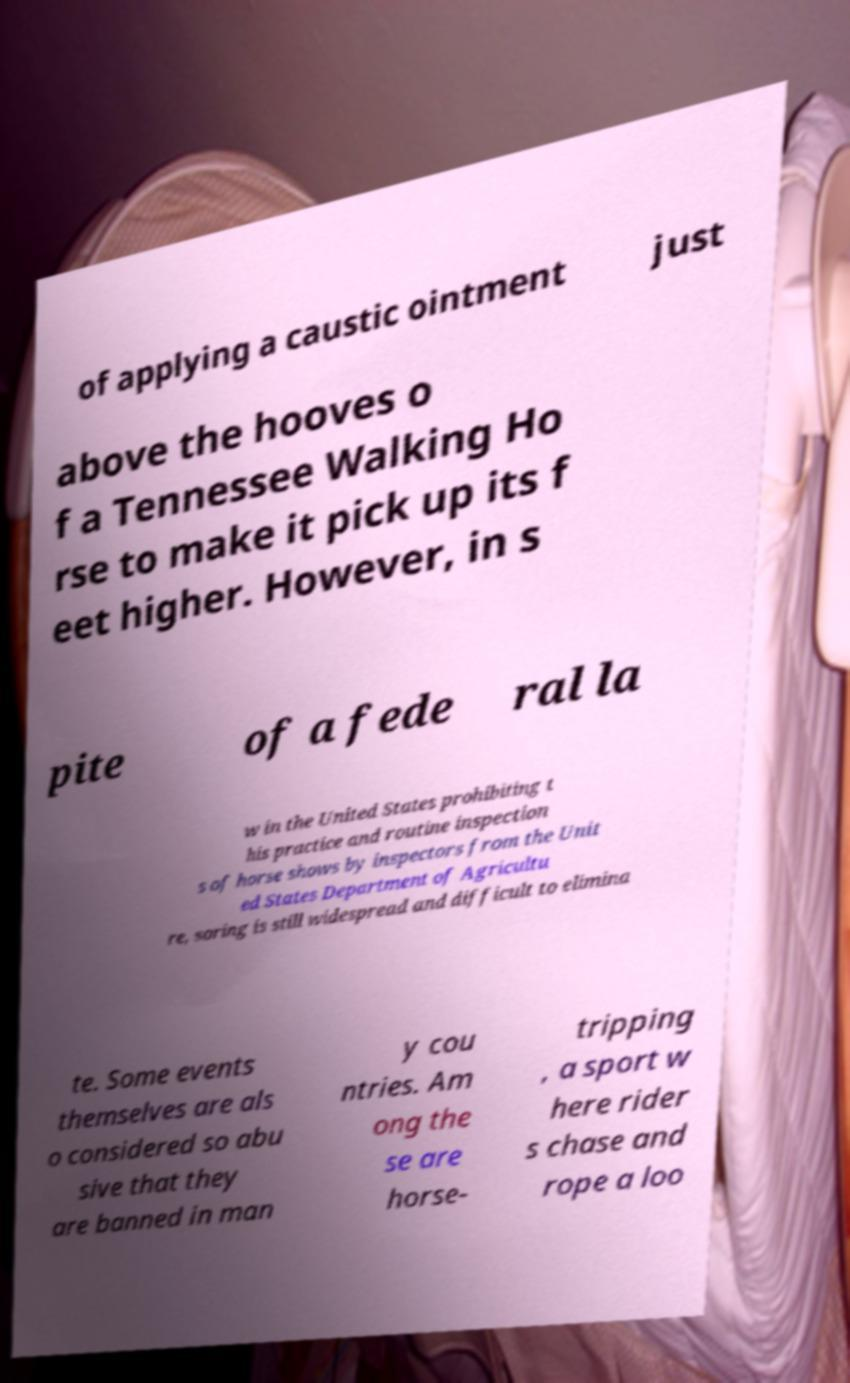There's text embedded in this image that I need extracted. Can you transcribe it verbatim? of applying a caustic ointment just above the hooves o f a Tennessee Walking Ho rse to make it pick up its f eet higher. However, in s pite of a fede ral la w in the United States prohibiting t his practice and routine inspection s of horse shows by inspectors from the Unit ed States Department of Agricultu re, soring is still widespread and difficult to elimina te. Some events themselves are als o considered so abu sive that they are banned in man y cou ntries. Am ong the se are horse- tripping , a sport w here rider s chase and rope a loo 